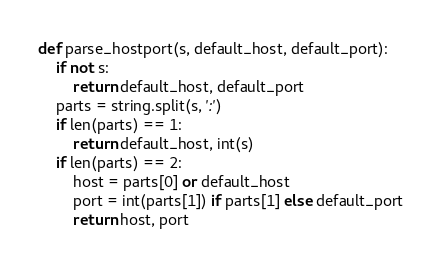Convert code to text. <code><loc_0><loc_0><loc_500><loc_500><_Python_>def parse_hostport(s, default_host, default_port):
	if not s:
		return default_host, default_port
	parts = string.split(s, ':')
	if len(parts) == 1:
		return default_host, int(s)
	if len(parts) == 2:
		host = parts[0] or default_host
		port = int(parts[1]) if parts[1] else default_port
		return host, port

</code> 